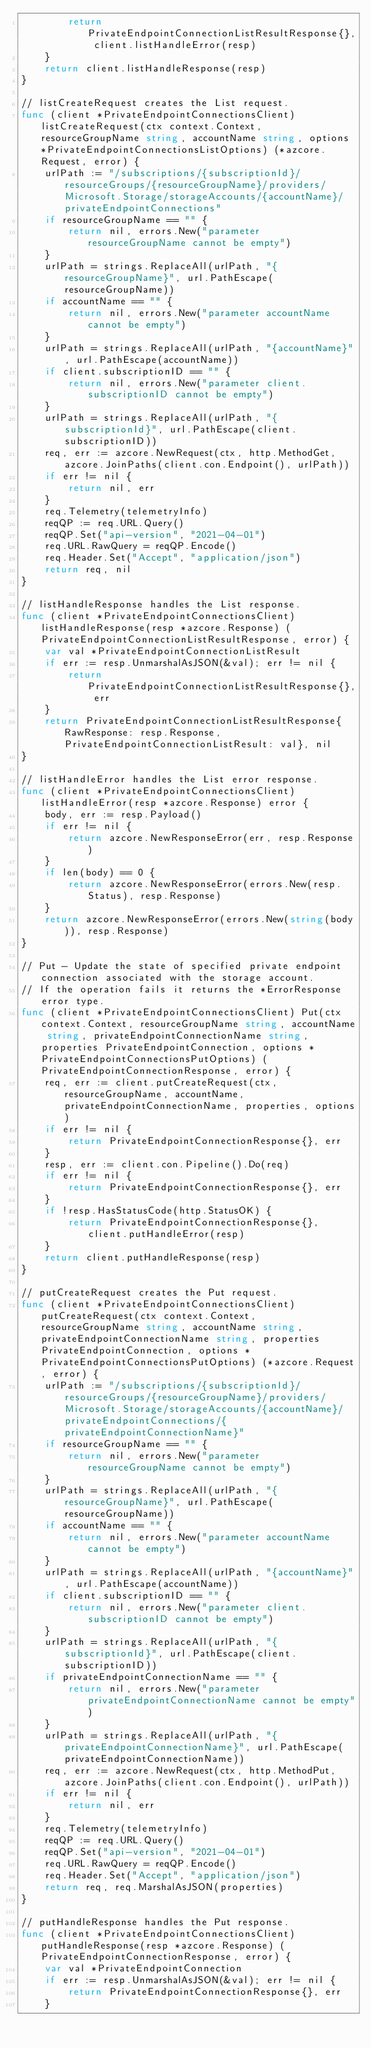<code> <loc_0><loc_0><loc_500><loc_500><_Go_>		return PrivateEndpointConnectionListResultResponse{}, client.listHandleError(resp)
	}
	return client.listHandleResponse(resp)
}

// listCreateRequest creates the List request.
func (client *PrivateEndpointConnectionsClient) listCreateRequest(ctx context.Context, resourceGroupName string, accountName string, options *PrivateEndpointConnectionsListOptions) (*azcore.Request, error) {
	urlPath := "/subscriptions/{subscriptionId}/resourceGroups/{resourceGroupName}/providers/Microsoft.Storage/storageAccounts/{accountName}/privateEndpointConnections"
	if resourceGroupName == "" {
		return nil, errors.New("parameter resourceGroupName cannot be empty")
	}
	urlPath = strings.ReplaceAll(urlPath, "{resourceGroupName}", url.PathEscape(resourceGroupName))
	if accountName == "" {
		return nil, errors.New("parameter accountName cannot be empty")
	}
	urlPath = strings.ReplaceAll(urlPath, "{accountName}", url.PathEscape(accountName))
	if client.subscriptionID == "" {
		return nil, errors.New("parameter client.subscriptionID cannot be empty")
	}
	urlPath = strings.ReplaceAll(urlPath, "{subscriptionId}", url.PathEscape(client.subscriptionID))
	req, err := azcore.NewRequest(ctx, http.MethodGet, azcore.JoinPaths(client.con.Endpoint(), urlPath))
	if err != nil {
		return nil, err
	}
	req.Telemetry(telemetryInfo)
	reqQP := req.URL.Query()
	reqQP.Set("api-version", "2021-04-01")
	req.URL.RawQuery = reqQP.Encode()
	req.Header.Set("Accept", "application/json")
	return req, nil
}

// listHandleResponse handles the List response.
func (client *PrivateEndpointConnectionsClient) listHandleResponse(resp *azcore.Response) (PrivateEndpointConnectionListResultResponse, error) {
	var val *PrivateEndpointConnectionListResult
	if err := resp.UnmarshalAsJSON(&val); err != nil {
		return PrivateEndpointConnectionListResultResponse{}, err
	}
	return PrivateEndpointConnectionListResultResponse{RawResponse: resp.Response, PrivateEndpointConnectionListResult: val}, nil
}

// listHandleError handles the List error response.
func (client *PrivateEndpointConnectionsClient) listHandleError(resp *azcore.Response) error {
	body, err := resp.Payload()
	if err != nil {
		return azcore.NewResponseError(err, resp.Response)
	}
	if len(body) == 0 {
		return azcore.NewResponseError(errors.New(resp.Status), resp.Response)
	}
	return azcore.NewResponseError(errors.New(string(body)), resp.Response)
}

// Put - Update the state of specified private endpoint connection associated with the storage account.
// If the operation fails it returns the *ErrorResponse error type.
func (client *PrivateEndpointConnectionsClient) Put(ctx context.Context, resourceGroupName string, accountName string, privateEndpointConnectionName string, properties PrivateEndpointConnection, options *PrivateEndpointConnectionsPutOptions) (PrivateEndpointConnectionResponse, error) {
	req, err := client.putCreateRequest(ctx, resourceGroupName, accountName, privateEndpointConnectionName, properties, options)
	if err != nil {
		return PrivateEndpointConnectionResponse{}, err
	}
	resp, err := client.con.Pipeline().Do(req)
	if err != nil {
		return PrivateEndpointConnectionResponse{}, err
	}
	if !resp.HasStatusCode(http.StatusOK) {
		return PrivateEndpointConnectionResponse{}, client.putHandleError(resp)
	}
	return client.putHandleResponse(resp)
}

// putCreateRequest creates the Put request.
func (client *PrivateEndpointConnectionsClient) putCreateRequest(ctx context.Context, resourceGroupName string, accountName string, privateEndpointConnectionName string, properties PrivateEndpointConnection, options *PrivateEndpointConnectionsPutOptions) (*azcore.Request, error) {
	urlPath := "/subscriptions/{subscriptionId}/resourceGroups/{resourceGroupName}/providers/Microsoft.Storage/storageAccounts/{accountName}/privateEndpointConnections/{privateEndpointConnectionName}"
	if resourceGroupName == "" {
		return nil, errors.New("parameter resourceGroupName cannot be empty")
	}
	urlPath = strings.ReplaceAll(urlPath, "{resourceGroupName}", url.PathEscape(resourceGroupName))
	if accountName == "" {
		return nil, errors.New("parameter accountName cannot be empty")
	}
	urlPath = strings.ReplaceAll(urlPath, "{accountName}", url.PathEscape(accountName))
	if client.subscriptionID == "" {
		return nil, errors.New("parameter client.subscriptionID cannot be empty")
	}
	urlPath = strings.ReplaceAll(urlPath, "{subscriptionId}", url.PathEscape(client.subscriptionID))
	if privateEndpointConnectionName == "" {
		return nil, errors.New("parameter privateEndpointConnectionName cannot be empty")
	}
	urlPath = strings.ReplaceAll(urlPath, "{privateEndpointConnectionName}", url.PathEscape(privateEndpointConnectionName))
	req, err := azcore.NewRequest(ctx, http.MethodPut, azcore.JoinPaths(client.con.Endpoint(), urlPath))
	if err != nil {
		return nil, err
	}
	req.Telemetry(telemetryInfo)
	reqQP := req.URL.Query()
	reqQP.Set("api-version", "2021-04-01")
	req.URL.RawQuery = reqQP.Encode()
	req.Header.Set("Accept", "application/json")
	return req, req.MarshalAsJSON(properties)
}

// putHandleResponse handles the Put response.
func (client *PrivateEndpointConnectionsClient) putHandleResponse(resp *azcore.Response) (PrivateEndpointConnectionResponse, error) {
	var val *PrivateEndpointConnection
	if err := resp.UnmarshalAsJSON(&val); err != nil {
		return PrivateEndpointConnectionResponse{}, err
	}</code> 